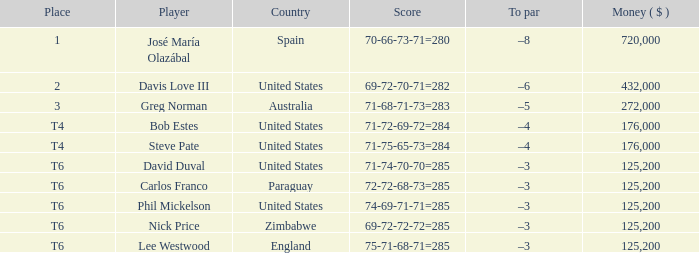Can you give me this table as a dict? {'header': ['Place', 'Player', 'Country', 'Score', 'To par', 'Money ( $ )'], 'rows': [['1', 'José María Olazábal', 'Spain', '70-66-73-71=280', '–8', '720,000'], ['2', 'Davis Love III', 'United States', '69-72-70-71=282', '–6', '432,000'], ['3', 'Greg Norman', 'Australia', '71-68-71-73=283', '–5', '272,000'], ['T4', 'Bob Estes', 'United States', '71-72-69-72=284', '–4', '176,000'], ['T4', 'Steve Pate', 'United States', '71-75-65-73=284', '–4', '176,000'], ['T6', 'David Duval', 'United States', '71-74-70-70=285', '–3', '125,200'], ['T6', 'Carlos Franco', 'Paraguay', '72-72-68-73=285', '–3', '125,200'], ['T6', 'Phil Mickelson', 'United States', '74-69-71-71=285', '–3', '125,200'], ['T6', 'Nick Price', 'Zimbabwe', '69-72-72-72=285', '–3', '125,200'], ['T6', 'Lee Westwood', 'England', '75-71-68-71=285', '–3', '125,200']]} Which location has a top score of -8? 1.0. 